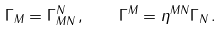<formula> <loc_0><loc_0><loc_500><loc_500>\Gamma _ { M } = \Gamma ^ { N } _ { M N } \, , \quad \Gamma ^ { M } = \eta ^ { M N } \Gamma _ { N } \, .</formula> 